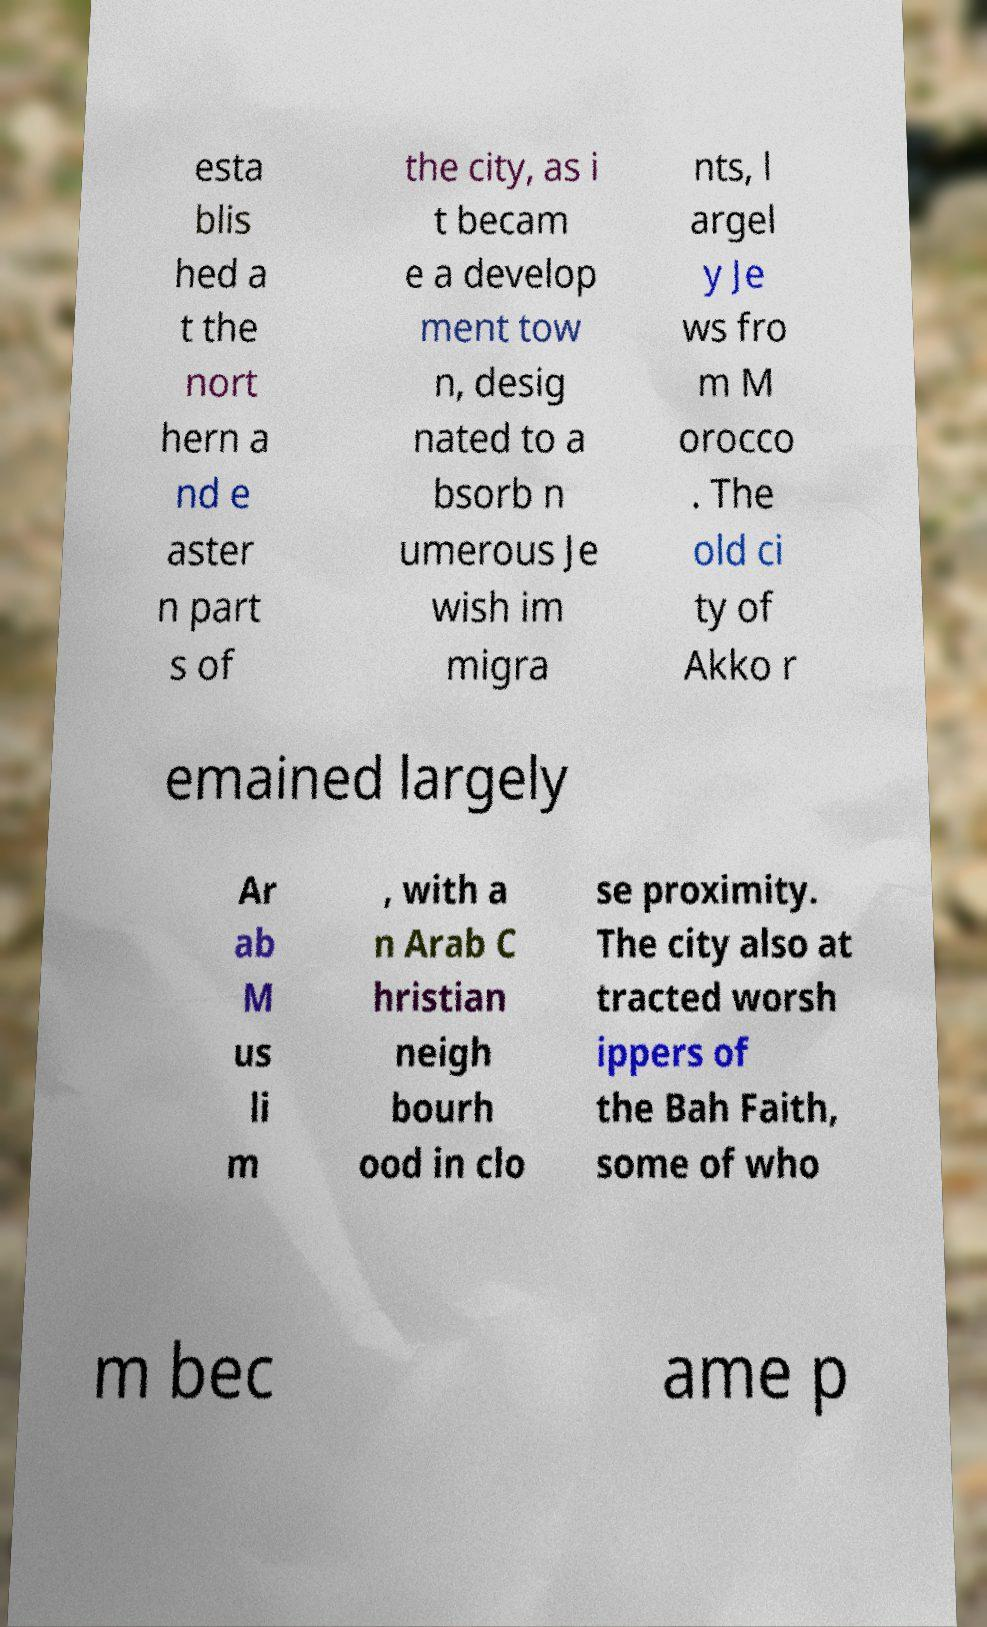Could you extract and type out the text from this image? esta blis hed a t the nort hern a nd e aster n part s of the city, as i t becam e a develop ment tow n, desig nated to a bsorb n umerous Je wish im migra nts, l argel y Je ws fro m M orocco . The old ci ty of Akko r emained largely Ar ab M us li m , with a n Arab C hristian neigh bourh ood in clo se proximity. The city also at tracted worsh ippers of the Bah Faith, some of who m bec ame p 